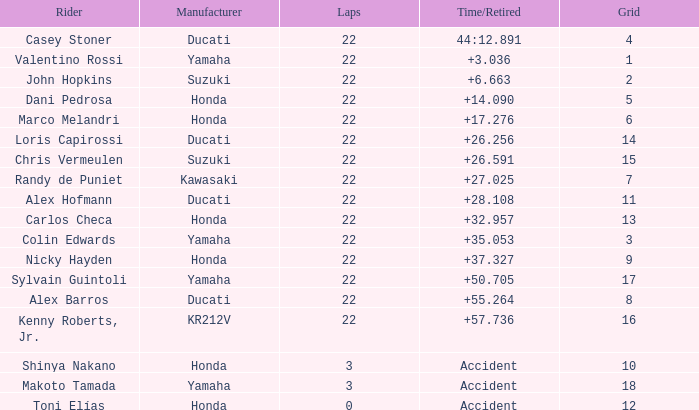276? None. 